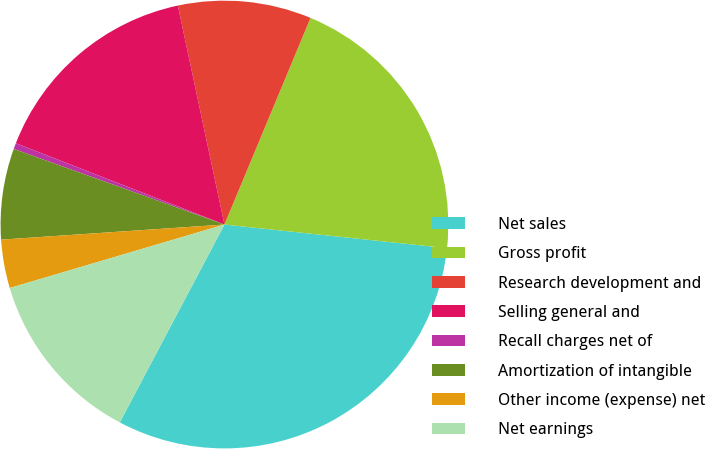<chart> <loc_0><loc_0><loc_500><loc_500><pie_chart><fcel>Net sales<fcel>Gross profit<fcel>Research development and<fcel>Selling general and<fcel>Recall charges net of<fcel>Amortization of intangible<fcel>Other income (expense) net<fcel>Net earnings<nl><fcel>31.06%<fcel>20.4%<fcel>9.62%<fcel>15.75%<fcel>0.43%<fcel>6.56%<fcel>3.5%<fcel>12.68%<nl></chart> 